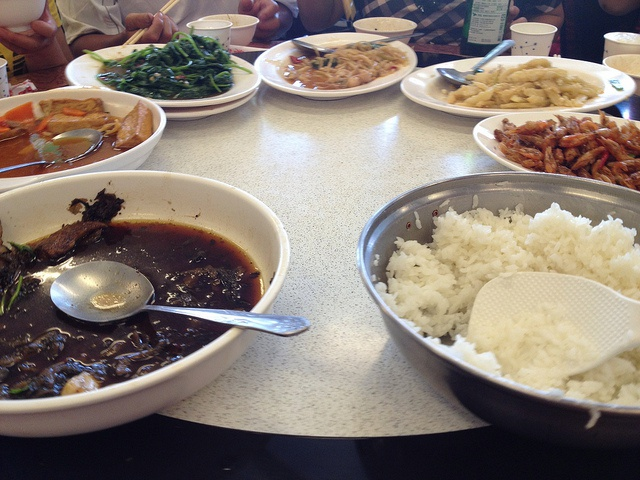Describe the objects in this image and their specific colors. I can see dining table in gray, lightgray, and darkgray tones, bowl in gray, tan, and black tones, bowl in gray, black, tan, and darkgray tones, spoon in gray, tan, and lightgray tones, and bowl in gray, brown, maroon, and darkgray tones in this image. 